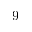Convert formula to latex. <formula><loc_0><loc_0><loc_500><loc_500>9</formula> 